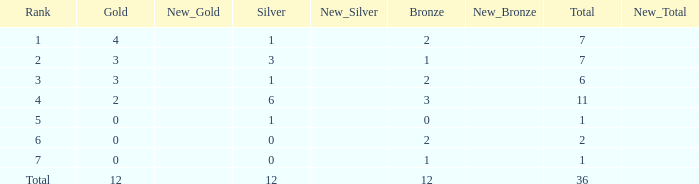What is the largest total for a team with 1 bronze, 0 gold medals and ranking of 7? None. 